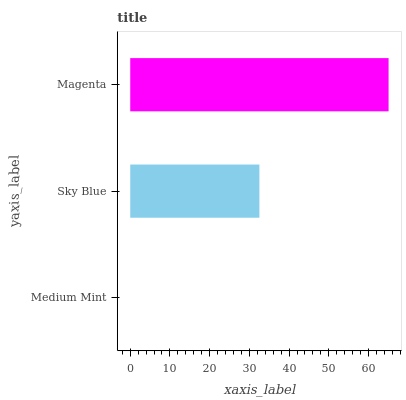Is Medium Mint the minimum?
Answer yes or no. Yes. Is Magenta the maximum?
Answer yes or no. Yes. Is Sky Blue the minimum?
Answer yes or no. No. Is Sky Blue the maximum?
Answer yes or no. No. Is Sky Blue greater than Medium Mint?
Answer yes or no. Yes. Is Medium Mint less than Sky Blue?
Answer yes or no. Yes. Is Medium Mint greater than Sky Blue?
Answer yes or no. No. Is Sky Blue less than Medium Mint?
Answer yes or no. No. Is Sky Blue the high median?
Answer yes or no. Yes. Is Sky Blue the low median?
Answer yes or no. Yes. Is Magenta the high median?
Answer yes or no. No. Is Magenta the low median?
Answer yes or no. No. 